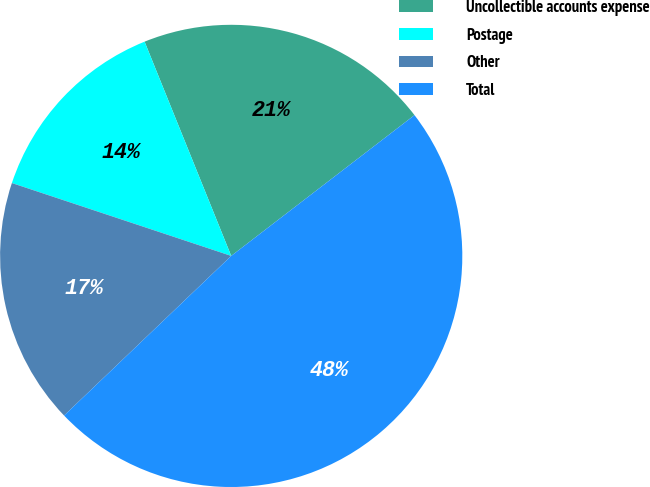<chart> <loc_0><loc_0><loc_500><loc_500><pie_chart><fcel>Uncollectible accounts expense<fcel>Postage<fcel>Other<fcel>Total<nl><fcel>20.69%<fcel>13.78%<fcel>17.24%<fcel>48.29%<nl></chart> 